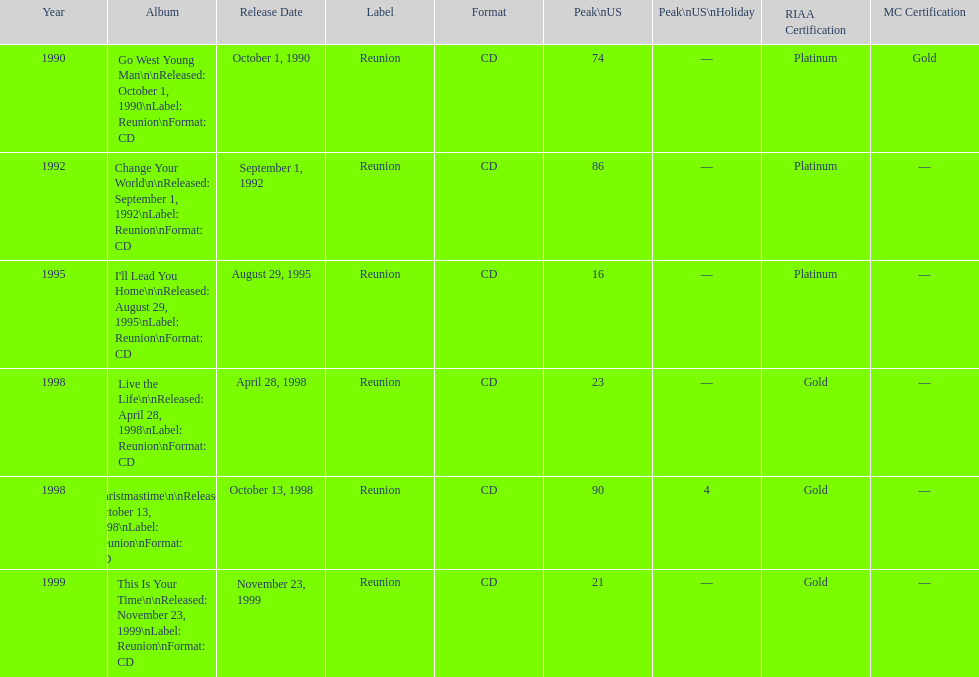What was the first michael w smith album? Go West Young Man. 